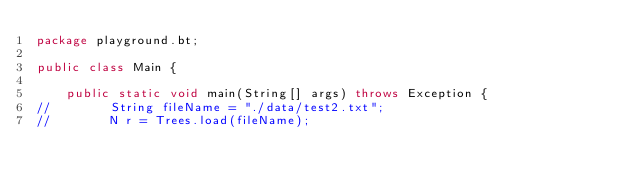Convert code to text. <code><loc_0><loc_0><loc_500><loc_500><_Java_>package playground.bt;

public class Main {

    public static void main(String[] args) throws Exception {
//        String fileName = "./data/test2.txt";
//        N r = Trees.load(fileName);</code> 